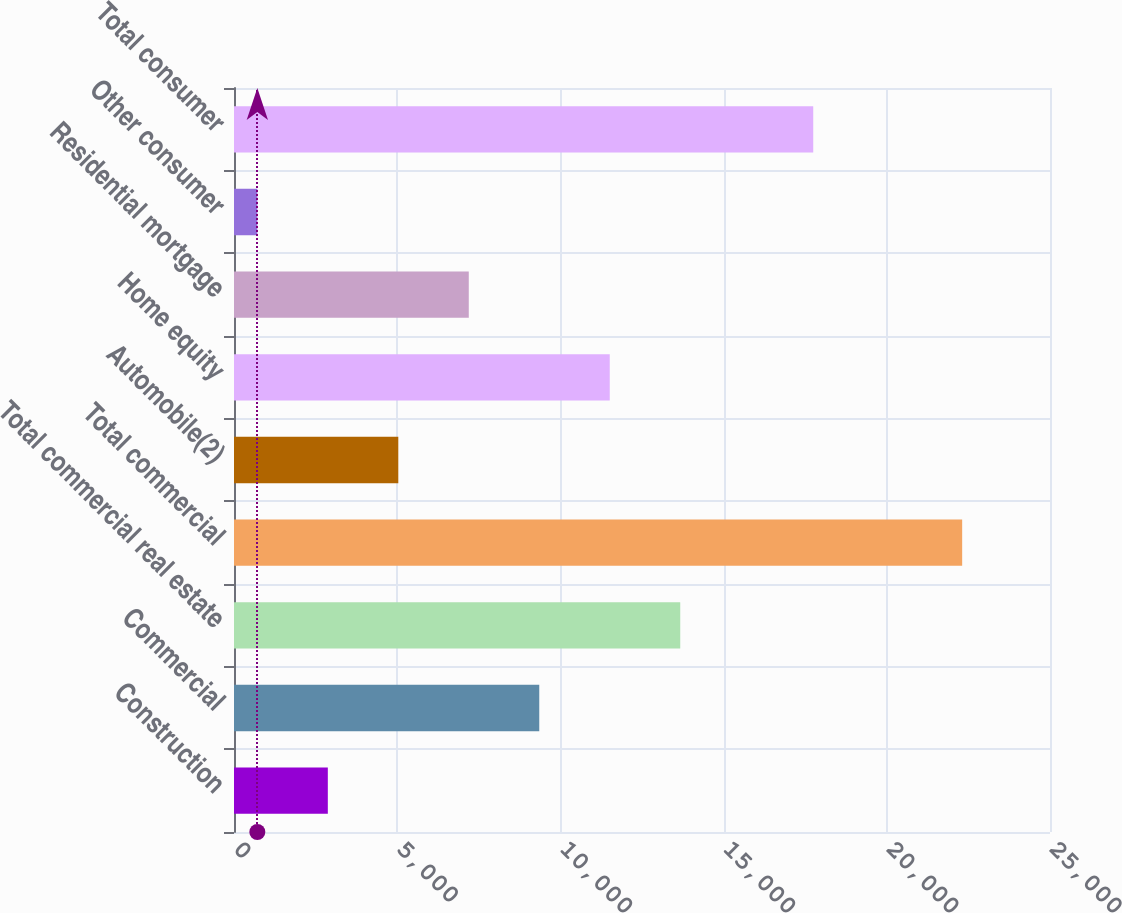Convert chart. <chart><loc_0><loc_0><loc_500><loc_500><bar_chart><fcel>Construction<fcel>Commercial<fcel>Total commercial real estate<fcel>Total commercial<fcel>Automobile(2)<fcel>Home equity<fcel>Residential mortgage<fcel>Other consumer<fcel>Total consumer<nl><fcel>2874.4<fcel>9352.6<fcel>13671.4<fcel>22309<fcel>5033.8<fcel>11512<fcel>7193.2<fcel>715<fcel>17746<nl></chart> 